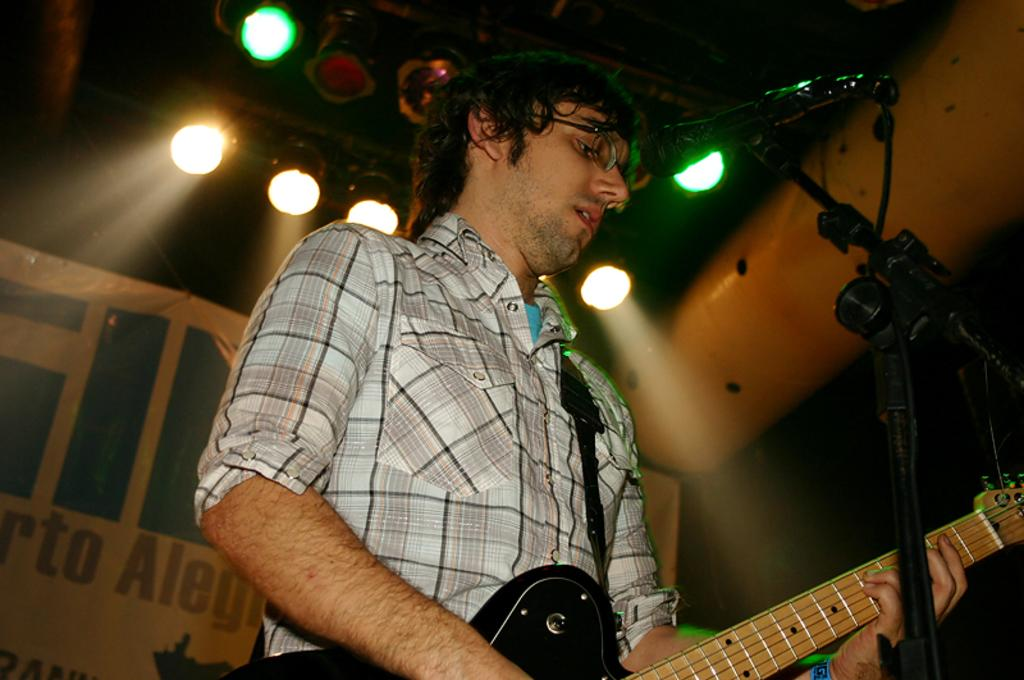What is the man in the image doing? The man is playing a guitar. What is in front of the man? There is a microphone in front of the man. What is the man wearing? The man is wearing a checkered shirt. What can be seen in the background of the image? There is a banner in the background of the image. What else is visible in the image? There are lights visible in the image. Can you see any bones sticking out of the man's apparel in the image? There are no bones visible in the image, nor are there any bones sticking out of the man's apparel. 